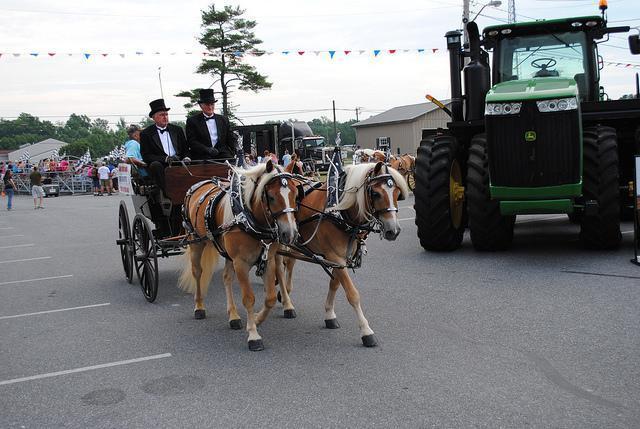How many horses are there?
Give a very brief answer. 2. How many top hats are there?
Give a very brief answer. 2. How many people are there?
Give a very brief answer. 3. How many vases are there?
Give a very brief answer. 0. 